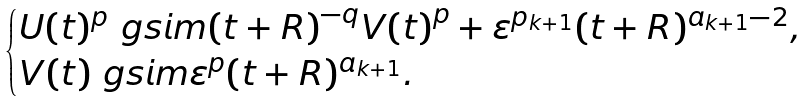Convert formula to latex. <formula><loc_0><loc_0><loc_500><loc_500>\begin{cases} U ( t ) ^ { p } \ g s i m { ( t + R ) } ^ { - q } { V ( t ) } ^ { p } + \varepsilon ^ { p _ { k + 1 } } ( t + R ) ^ { a _ { k + 1 } - 2 } , \\ V ( t ) \ g s i m \varepsilon ^ { p } ( t + R ) ^ { a _ { k + 1 } } . \end{cases}</formula> 